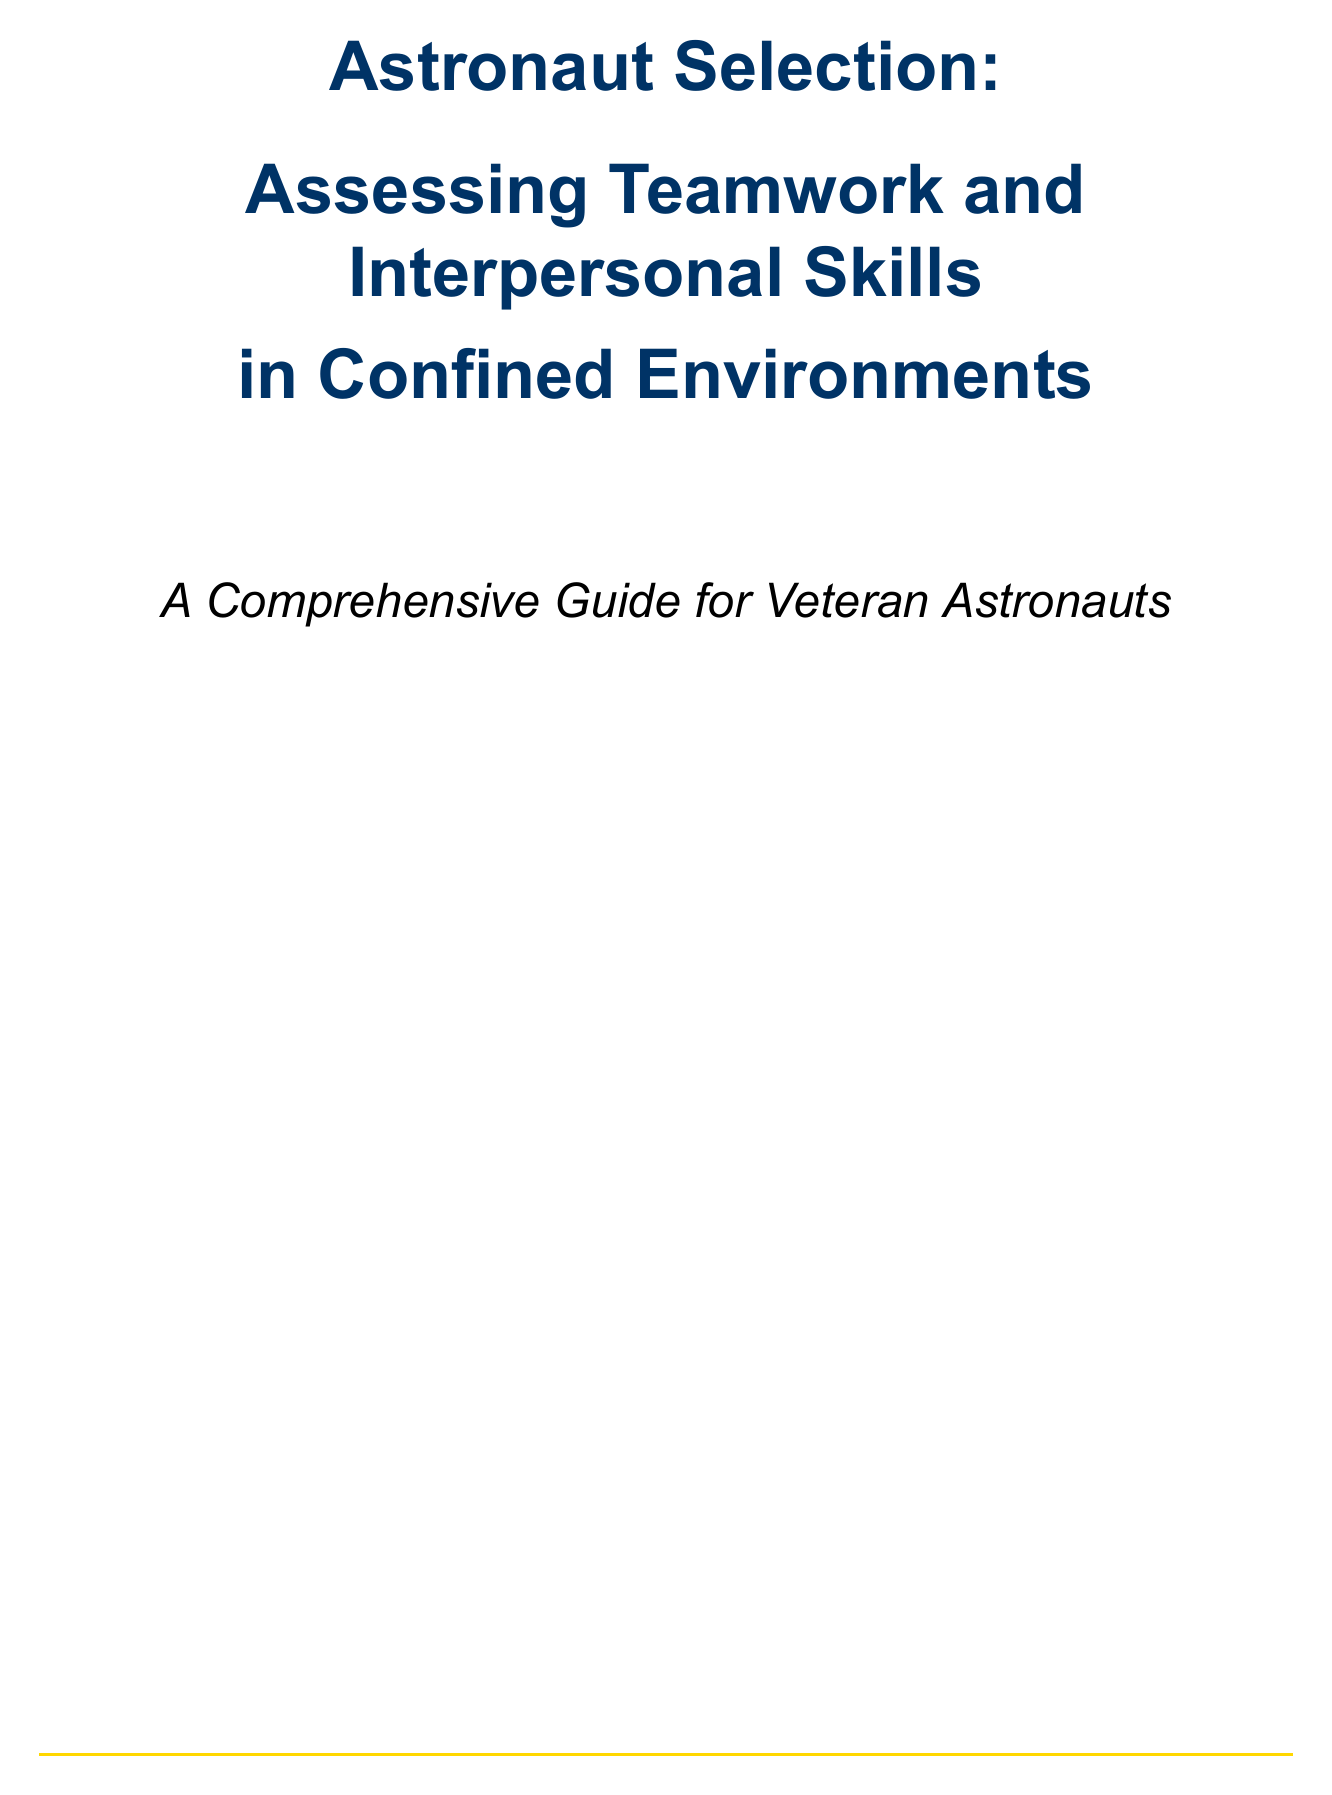What is the title of the manual? The title is specified at the beginning of the document and is "Astronaut Selection: Assessing Teamwork and Interpersonal Skills in Confined Environments."
Answer: Astronaut Selection: Assessing Teamwork and Interpersonal Skills in Confined Environments How long is the isolation experiment in the HERA facility? The manual specifies that the isolation experiment lasts for 45 days.
Answer: 45 days What assessment tool is used for evaluating communication skills? The document mentions NASA's Communication Skills Assessment Tool (CSAT) for this purpose.
Answer: NASA's Communication Skills Assessment Tool (CSAT) What is the minimum score required in all areas for candidates to be considered for space missions? According to the evaluation criteria section, candidates must score at least 4 in all areas.
Answer: 4 Which questionnaire is used to assess reintegration capabilities post-isolation? The European Astronaut Centre's Post-Mission Adaptation Questionnaire is used for this evaluation.
Answer: European Astronaut Centre's Post-Mission Adaptation Questionnaire What method is used for daily mood assessments during long-duration isolation? The document states that daily assessments are conducted using the ISS Crew Discretionary Event (CDE) system.
Answer: ISS Crew Discretionary Event (CDE) system What is the focus of the evaluation at the Mars Desert Research Station (MDRS)? The evaluation at MDRS focuses on team cohesion and performance under stress.
Answer: team cohesion and performance under stress Which framework is the training based on for team performance assessments? The manual mentions the Team Dimensional Training (TDT) framework as the basis for training in evaluations.
Answer: Team Dimensional Training (TDT) framework 